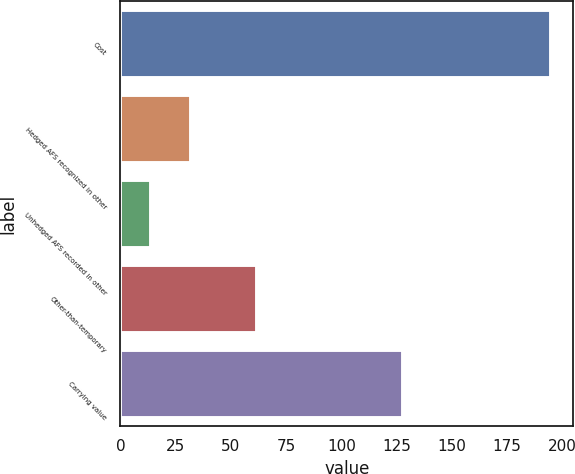<chart> <loc_0><loc_0><loc_500><loc_500><bar_chart><fcel>Cost<fcel>Hedged AFS recognized in other<fcel>Unhedged AFS recorded in other<fcel>Other-than-temporary<fcel>Carrying value<nl><fcel>195<fcel>32.1<fcel>14<fcel>62<fcel>128<nl></chart> 